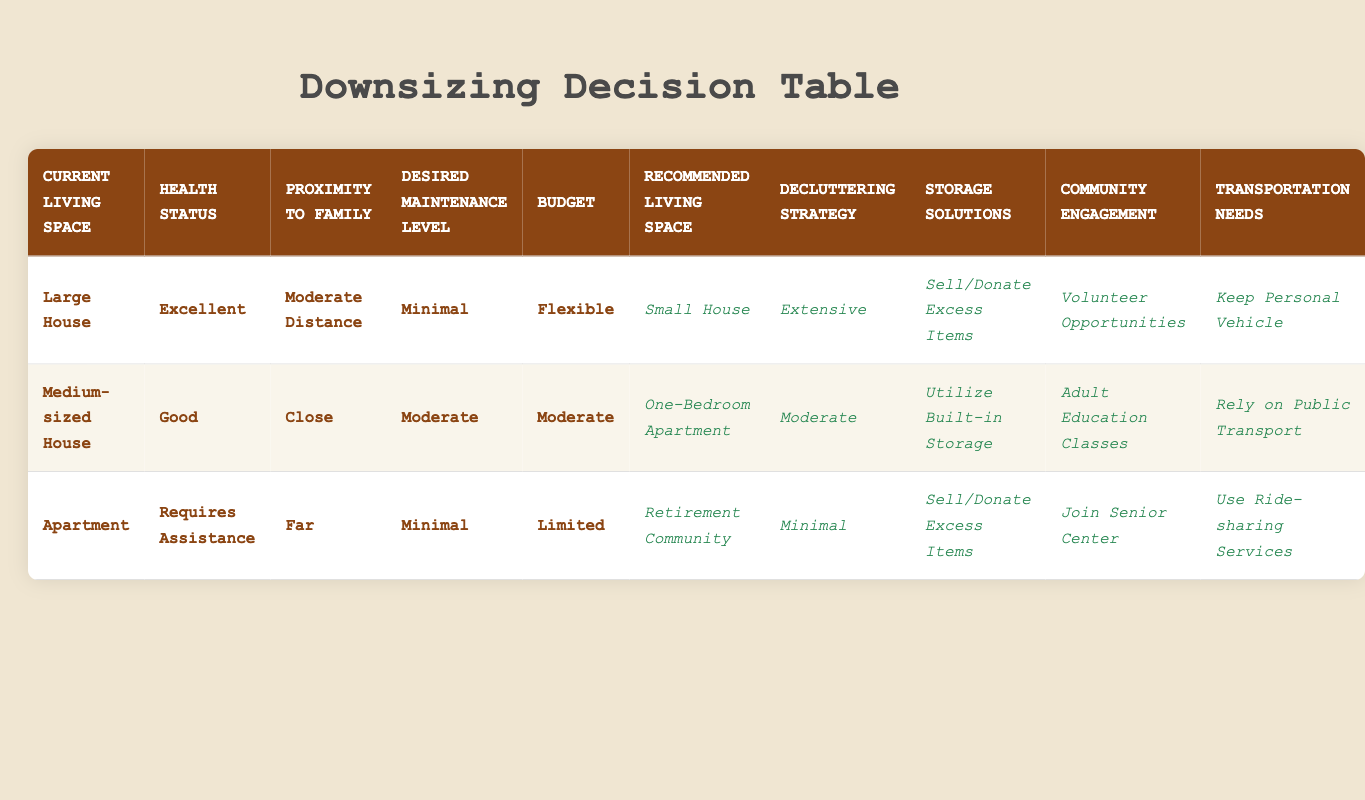What is the recommended living space for someone currently in a large house with excellent health, living a moderate distance from family, desiring minimal maintenance, and who has a flexible budget? According to the table, this specific set of conditions leads to the recommended living space being a small house. The answer can be obtained directly from the corresponding row in the table where all these conditions match.
Answer: Small House What decluttering strategy is recommended for someone living in a medium-sized house who has good health, family living close by, desires a moderate maintenance level, and has a moderate budget? The table indicates that for these conditions, a moderate decluttering strategy is recommended, which can be found on the same row that contains these specific conditions.
Answer: Moderate Is there any recommended community engagement for someone living in an apartment who requires assistance and has family living far away, with minimal maintenance and a limited budget? Yes, the table suggests joining a senior center for community engagement in this scenario, as listed under the matching conditions.
Answer: Yes What are the transportation needs for individuals residing in a large house with excellent health and a flexible budget? The recommendation is to keep a personal vehicle, as stated in the relevant row for those conditions. This can be easily found by checking the transportation needs for the matching scenario.
Answer: Keep Personal Vehicle How does the storage solution for a person in an apartment requiring assistance with a limited budget differ from someone in a medium-sized house with good health, living close to family, who has a moderate budget? The person in the apartment is recommended to sell/donate excess items, while the person in the medium-sized house is suggested to utilize built-in storage. This comparison can be made by examining the storage solutions listed under the two different living situations in the table.
Answer: Sell/Donate Excess Items and Utilize Built-in Storage What is the average maintenance level desired by individuals in the table? To find the average, we look at the maintenance levels specified: Minimal (2), Moderate (2), and High (0). To calculate the average, we can assign values (Minimal = 1, Moderate = 2, High = 3), thus calculating (2*1 + 2*2 + 0*3) / 4 = (2 + 4 + 0) / 4 = 6 / 4 = 1.5 which corresponds to a range closer to Minimal.
Answer: 1.5 Does anyone in the table recommend staying in their current home? Yes, the table does not explicitly suggest staying in the current home for any combination of conditions. The relevant row does not appear, making the fact true.
Answer: No For someone currently in a large house with excellent health, living at a moderate distance from family and preferring a flexible budget, how many storage solutions are being recommended? From the row corresponding to these conditions, it shows that the storage solution recommended is to sell or donate excess items. Therefore, there is only one solution mentioned for these conditions.
Answer: One Which living space is recommended for individuals living in an apartment who requires assistance and has a limited budget? The table states that a retirement community is the recommended living space for individuals with these specific conditions. This information is directly available from the relevant row.
Answer: Retirement Community 